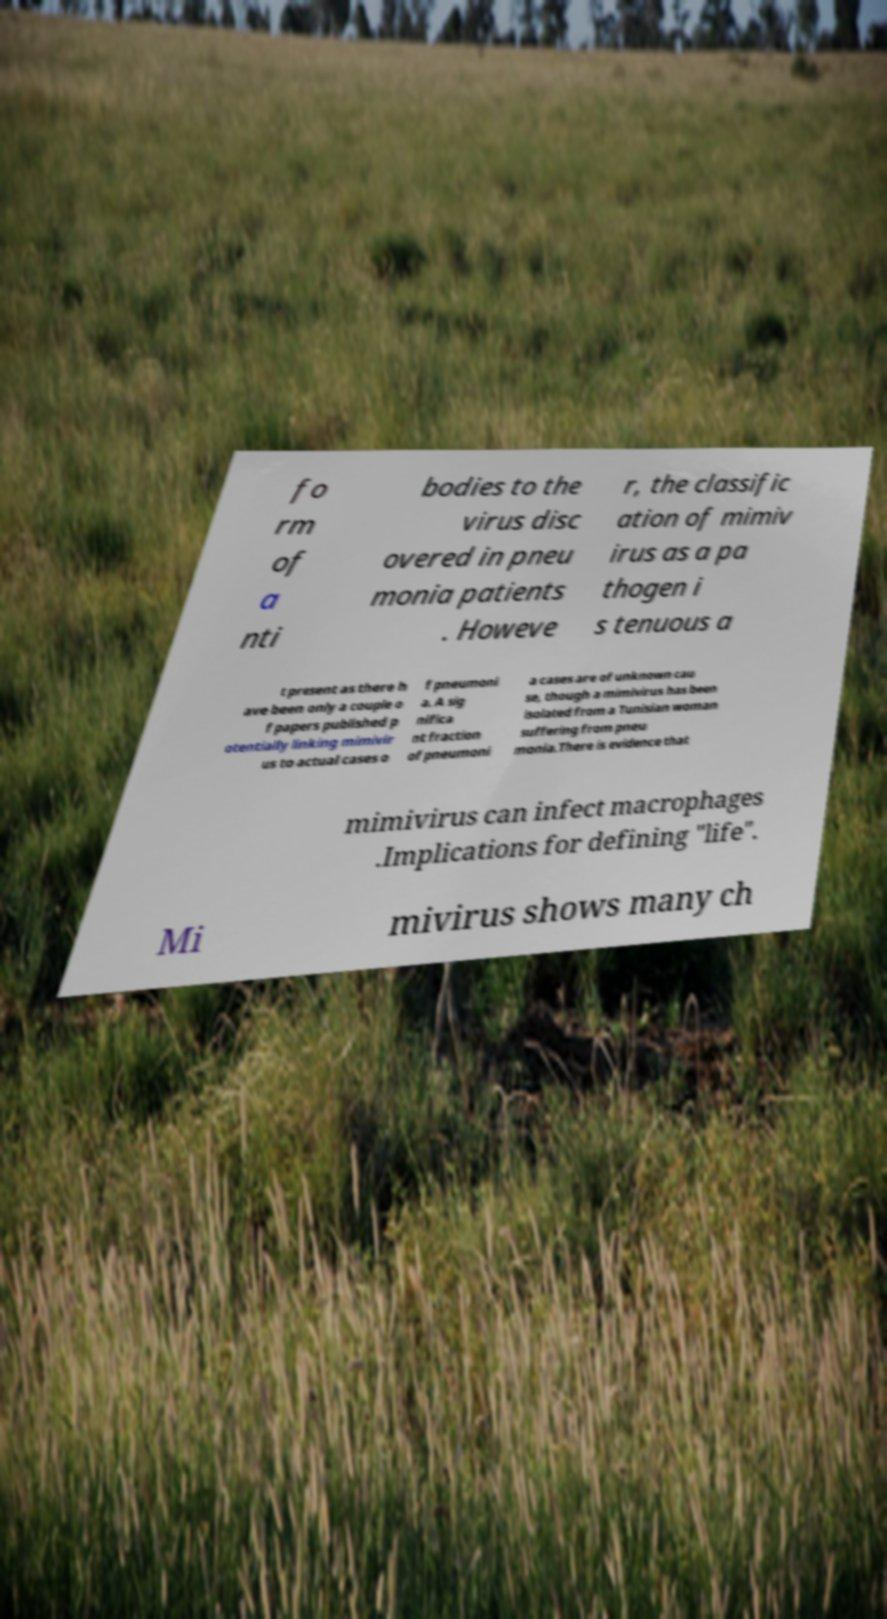Please read and relay the text visible in this image. What does it say? fo rm of a nti bodies to the virus disc overed in pneu monia patients . Howeve r, the classific ation of mimiv irus as a pa thogen i s tenuous a t present as there h ave been only a couple o f papers published p otentially linking mimivir us to actual cases o f pneumoni a. A sig nifica nt fraction of pneumoni a cases are of unknown cau se, though a mimivirus has been isolated from a Tunisian woman suffering from pneu monia.There is evidence that mimivirus can infect macrophages .Implications for defining "life". Mi mivirus shows many ch 